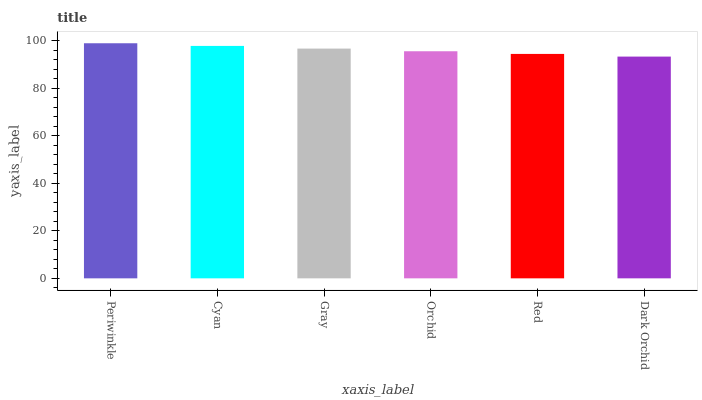Is Dark Orchid the minimum?
Answer yes or no. Yes. Is Periwinkle the maximum?
Answer yes or no. Yes. Is Cyan the minimum?
Answer yes or no. No. Is Cyan the maximum?
Answer yes or no. No. Is Periwinkle greater than Cyan?
Answer yes or no. Yes. Is Cyan less than Periwinkle?
Answer yes or no. Yes. Is Cyan greater than Periwinkle?
Answer yes or no. No. Is Periwinkle less than Cyan?
Answer yes or no. No. Is Gray the high median?
Answer yes or no. Yes. Is Orchid the low median?
Answer yes or no. Yes. Is Periwinkle the high median?
Answer yes or no. No. Is Red the low median?
Answer yes or no. No. 